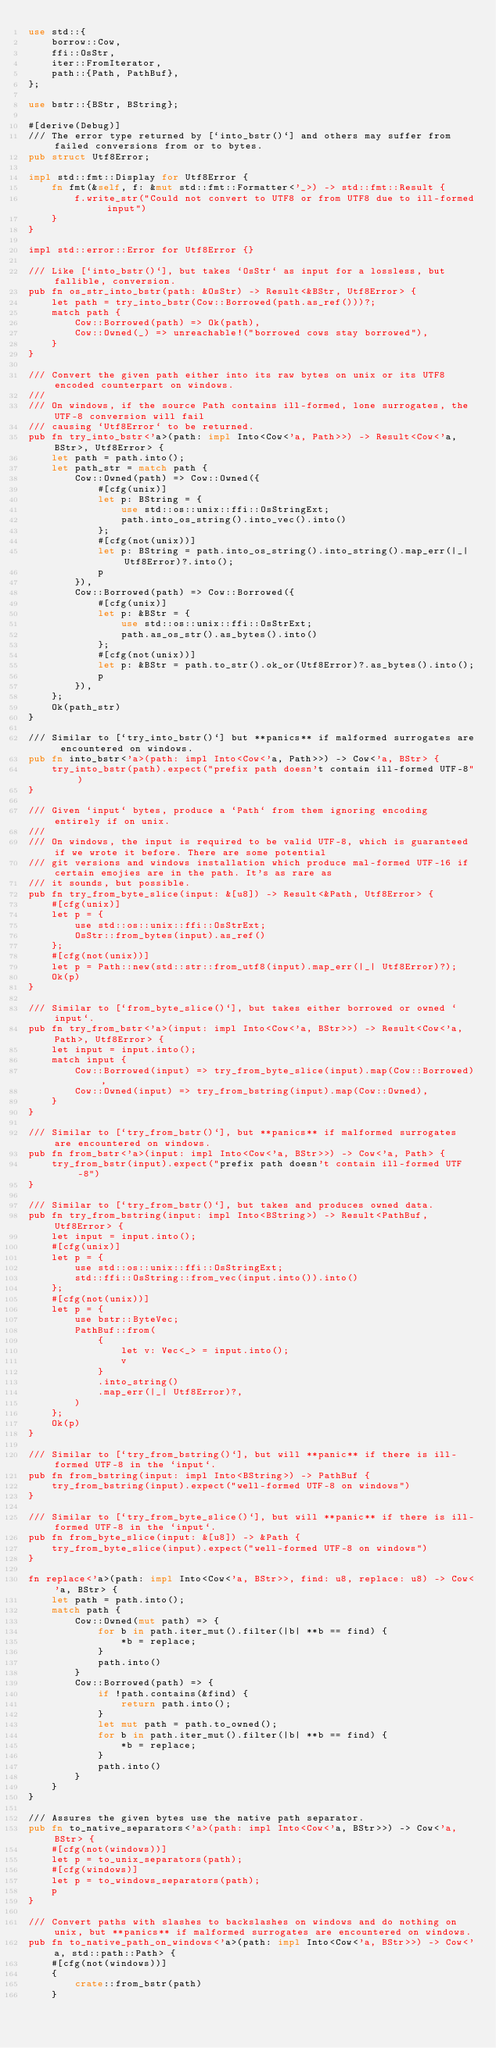<code> <loc_0><loc_0><loc_500><loc_500><_Rust_>use std::{
    borrow::Cow,
    ffi::OsStr,
    iter::FromIterator,
    path::{Path, PathBuf},
};

use bstr::{BStr, BString};

#[derive(Debug)]
/// The error type returned by [`into_bstr()`] and others may suffer from failed conversions from or to bytes.
pub struct Utf8Error;

impl std::fmt::Display for Utf8Error {
    fn fmt(&self, f: &mut std::fmt::Formatter<'_>) -> std::fmt::Result {
        f.write_str("Could not convert to UTF8 or from UTF8 due to ill-formed input")
    }
}

impl std::error::Error for Utf8Error {}

/// Like [`into_bstr()`], but takes `OsStr` as input for a lossless, but fallible, conversion.
pub fn os_str_into_bstr(path: &OsStr) -> Result<&BStr, Utf8Error> {
    let path = try_into_bstr(Cow::Borrowed(path.as_ref()))?;
    match path {
        Cow::Borrowed(path) => Ok(path),
        Cow::Owned(_) => unreachable!("borrowed cows stay borrowed"),
    }
}

/// Convert the given path either into its raw bytes on unix or its UTF8 encoded counterpart on windows.
///
/// On windows, if the source Path contains ill-formed, lone surrogates, the UTF-8 conversion will fail
/// causing `Utf8Error` to be returned.
pub fn try_into_bstr<'a>(path: impl Into<Cow<'a, Path>>) -> Result<Cow<'a, BStr>, Utf8Error> {
    let path = path.into();
    let path_str = match path {
        Cow::Owned(path) => Cow::Owned({
            #[cfg(unix)]
            let p: BString = {
                use std::os::unix::ffi::OsStringExt;
                path.into_os_string().into_vec().into()
            };
            #[cfg(not(unix))]
            let p: BString = path.into_os_string().into_string().map_err(|_| Utf8Error)?.into();
            p
        }),
        Cow::Borrowed(path) => Cow::Borrowed({
            #[cfg(unix)]
            let p: &BStr = {
                use std::os::unix::ffi::OsStrExt;
                path.as_os_str().as_bytes().into()
            };
            #[cfg(not(unix))]
            let p: &BStr = path.to_str().ok_or(Utf8Error)?.as_bytes().into();
            p
        }),
    };
    Ok(path_str)
}

/// Similar to [`try_into_bstr()`] but **panics** if malformed surrogates are encountered on windows.
pub fn into_bstr<'a>(path: impl Into<Cow<'a, Path>>) -> Cow<'a, BStr> {
    try_into_bstr(path).expect("prefix path doesn't contain ill-formed UTF-8")
}

/// Given `input` bytes, produce a `Path` from them ignoring encoding entirely if on unix.
///
/// On windows, the input is required to be valid UTF-8, which is guaranteed if we wrote it before. There are some potential
/// git versions and windows installation which produce mal-formed UTF-16 if certain emojies are in the path. It's as rare as
/// it sounds, but possible.
pub fn try_from_byte_slice(input: &[u8]) -> Result<&Path, Utf8Error> {
    #[cfg(unix)]
    let p = {
        use std::os::unix::ffi::OsStrExt;
        OsStr::from_bytes(input).as_ref()
    };
    #[cfg(not(unix))]
    let p = Path::new(std::str::from_utf8(input).map_err(|_| Utf8Error)?);
    Ok(p)
}

/// Similar to [`from_byte_slice()`], but takes either borrowed or owned `input`.
pub fn try_from_bstr<'a>(input: impl Into<Cow<'a, BStr>>) -> Result<Cow<'a, Path>, Utf8Error> {
    let input = input.into();
    match input {
        Cow::Borrowed(input) => try_from_byte_slice(input).map(Cow::Borrowed),
        Cow::Owned(input) => try_from_bstring(input).map(Cow::Owned),
    }
}

/// Similar to [`try_from_bstr()`], but **panics** if malformed surrogates are encountered on windows.
pub fn from_bstr<'a>(input: impl Into<Cow<'a, BStr>>) -> Cow<'a, Path> {
    try_from_bstr(input).expect("prefix path doesn't contain ill-formed UTF-8")
}

/// Similar to [`try_from_bstr()`], but takes and produces owned data.
pub fn try_from_bstring(input: impl Into<BString>) -> Result<PathBuf, Utf8Error> {
    let input = input.into();
    #[cfg(unix)]
    let p = {
        use std::os::unix::ffi::OsStringExt;
        std::ffi::OsString::from_vec(input.into()).into()
    };
    #[cfg(not(unix))]
    let p = {
        use bstr::ByteVec;
        PathBuf::from(
            {
                let v: Vec<_> = input.into();
                v
            }
            .into_string()
            .map_err(|_| Utf8Error)?,
        )
    };
    Ok(p)
}

/// Similar to [`try_from_bstring()`], but will **panic** if there is ill-formed UTF-8 in the `input`.
pub fn from_bstring(input: impl Into<BString>) -> PathBuf {
    try_from_bstring(input).expect("well-formed UTF-8 on windows")
}

/// Similar to [`try_from_byte_slice()`], but will **panic** if there is ill-formed UTF-8 in the `input`.
pub fn from_byte_slice(input: &[u8]) -> &Path {
    try_from_byte_slice(input).expect("well-formed UTF-8 on windows")
}

fn replace<'a>(path: impl Into<Cow<'a, BStr>>, find: u8, replace: u8) -> Cow<'a, BStr> {
    let path = path.into();
    match path {
        Cow::Owned(mut path) => {
            for b in path.iter_mut().filter(|b| **b == find) {
                *b = replace;
            }
            path.into()
        }
        Cow::Borrowed(path) => {
            if !path.contains(&find) {
                return path.into();
            }
            let mut path = path.to_owned();
            for b in path.iter_mut().filter(|b| **b == find) {
                *b = replace;
            }
            path.into()
        }
    }
}

/// Assures the given bytes use the native path separator.
pub fn to_native_separators<'a>(path: impl Into<Cow<'a, BStr>>) -> Cow<'a, BStr> {
    #[cfg(not(windows))]
    let p = to_unix_separators(path);
    #[cfg(windows)]
    let p = to_windows_separators(path);
    p
}

/// Convert paths with slashes to backslashes on windows and do nothing on unix, but **panics** if malformed surrogates are encountered on windows.
pub fn to_native_path_on_windows<'a>(path: impl Into<Cow<'a, BStr>>) -> Cow<'a, std::path::Path> {
    #[cfg(not(windows))]
    {
        crate::from_bstr(path)
    }</code> 